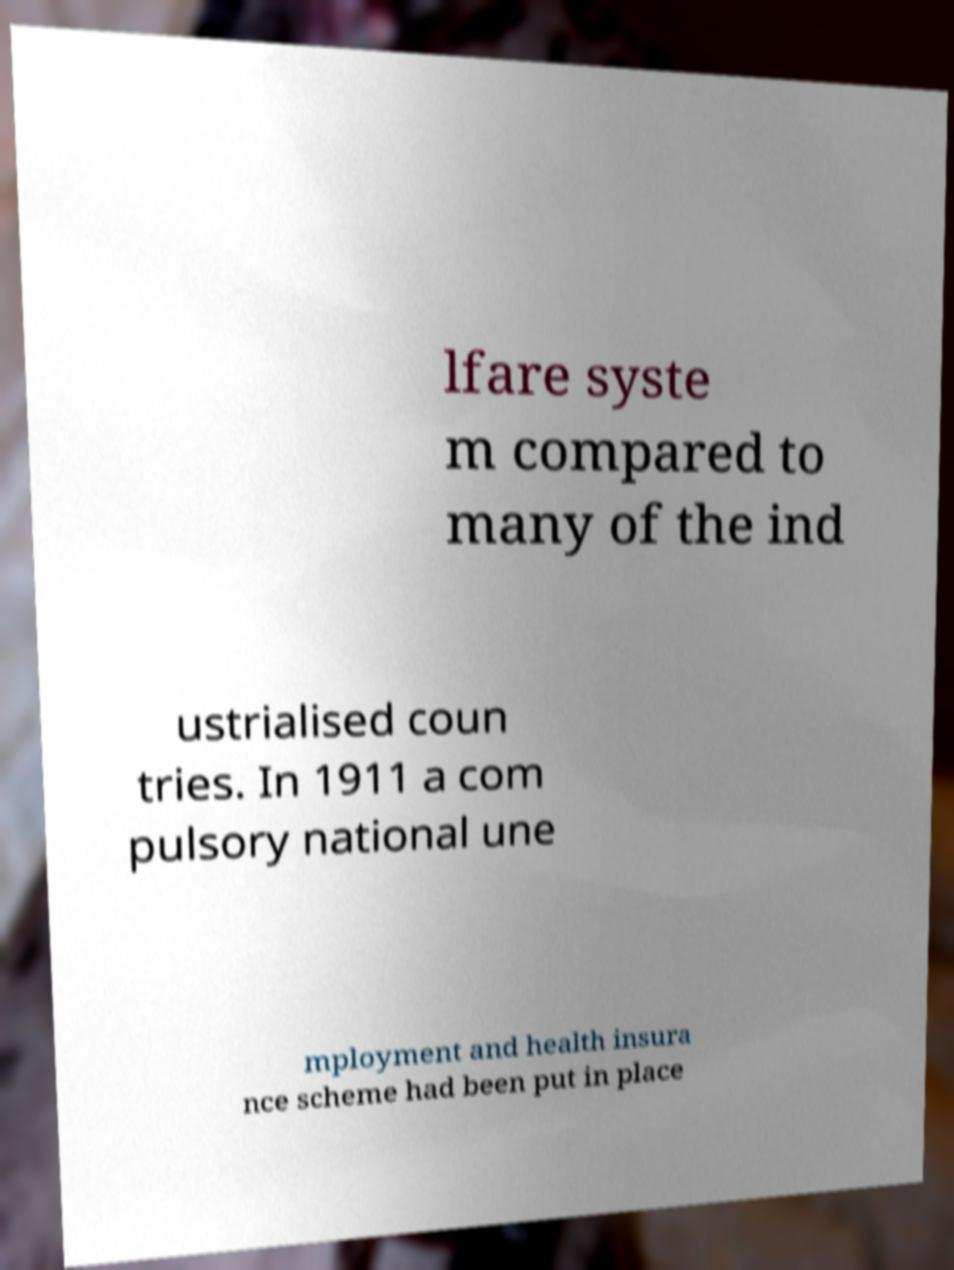Can you accurately transcribe the text from the provided image for me? lfare syste m compared to many of the ind ustrialised coun tries. In 1911 a com pulsory national une mployment and health insura nce scheme had been put in place 